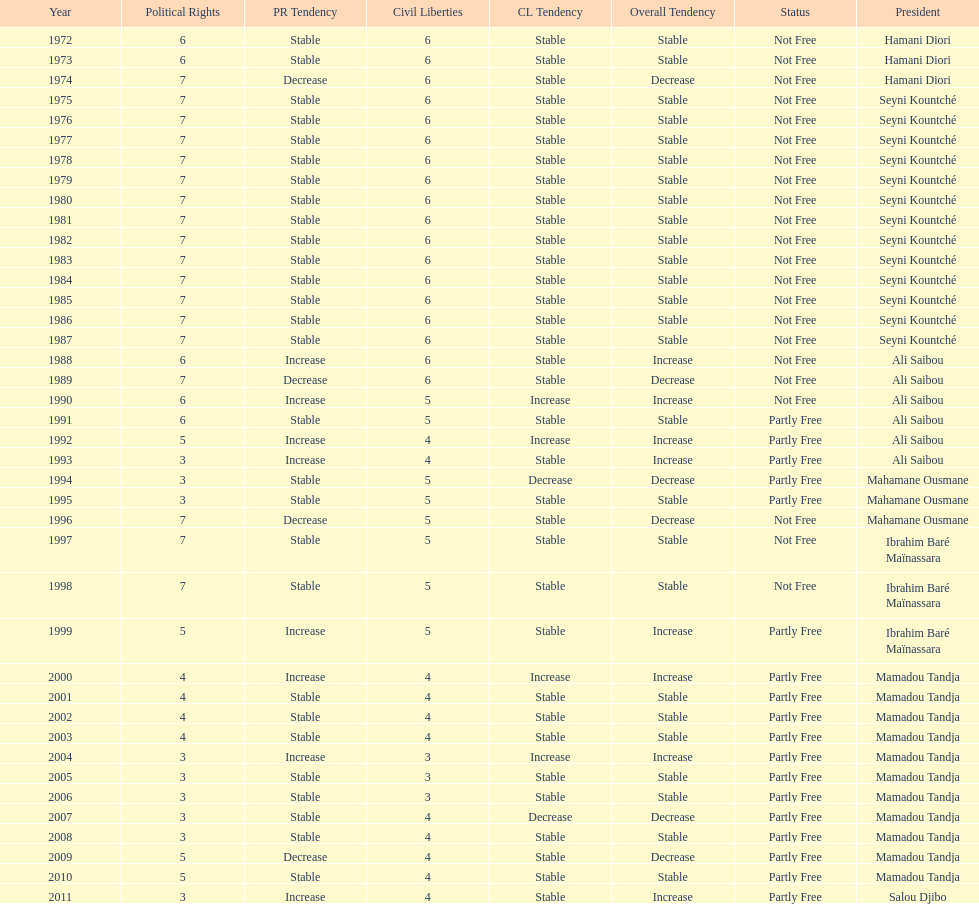Who was president before mamadou tandja? Ibrahim Baré Maïnassara. 